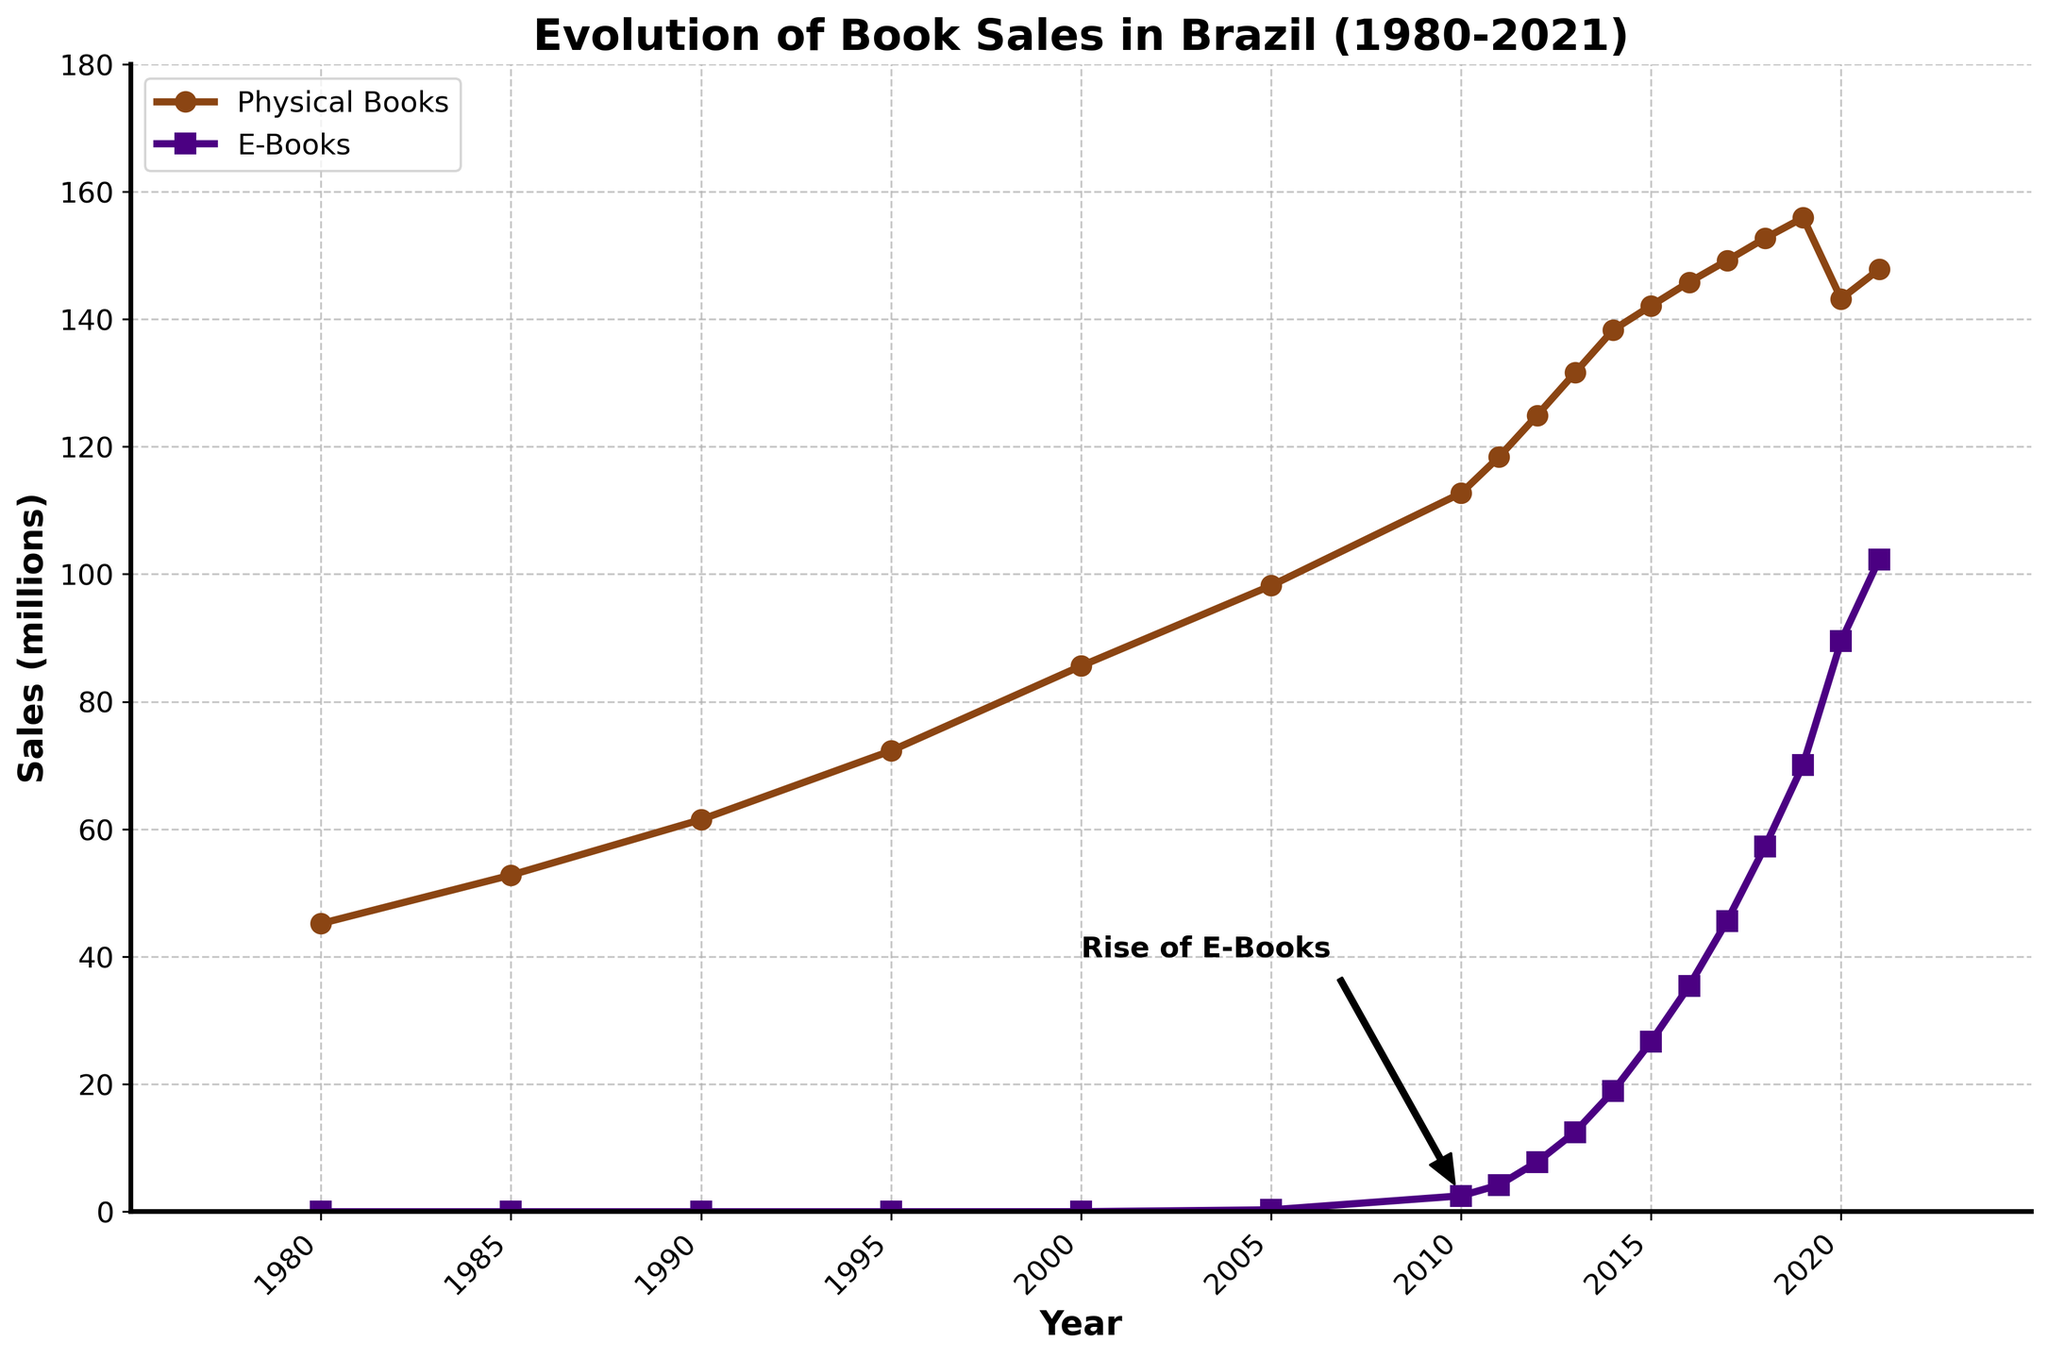What is the approximate difference in sales between physical books and e-books in the year 2021? To find the difference, subtract the sales of e-books from the sales of physical books in 2021: 147.8 - 102.3 = 45.5.
Answer: 45.5 million When did e-books sales start to notably increase, based on the annotation in the figure? The annotation points to the year 2010 as the start of a notable increase in e-book sales.
Answer: 2010 By how much did e-book sales change from 2005 to 2020? Find the difference in e-book sales between 2020 and 2005: 89.5 - 0.3 = 89.2.
Answer: 89.2 million 